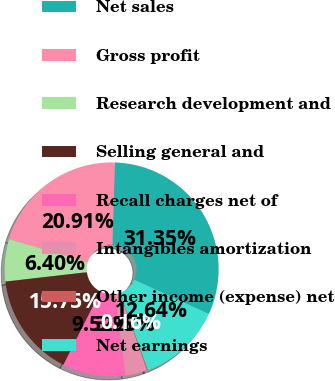Convert chart to OTSL. <chart><loc_0><loc_0><loc_500><loc_500><pie_chart><fcel>Net sales<fcel>Gross profit<fcel>Research development and<fcel>Selling general and<fcel>Recall charges net of<fcel>Intangibles amortization<fcel>Other income (expense) net<fcel>Net earnings<nl><fcel>31.35%<fcel>20.91%<fcel>6.4%<fcel>15.75%<fcel>9.52%<fcel>3.28%<fcel>0.16%<fcel>12.64%<nl></chart> 